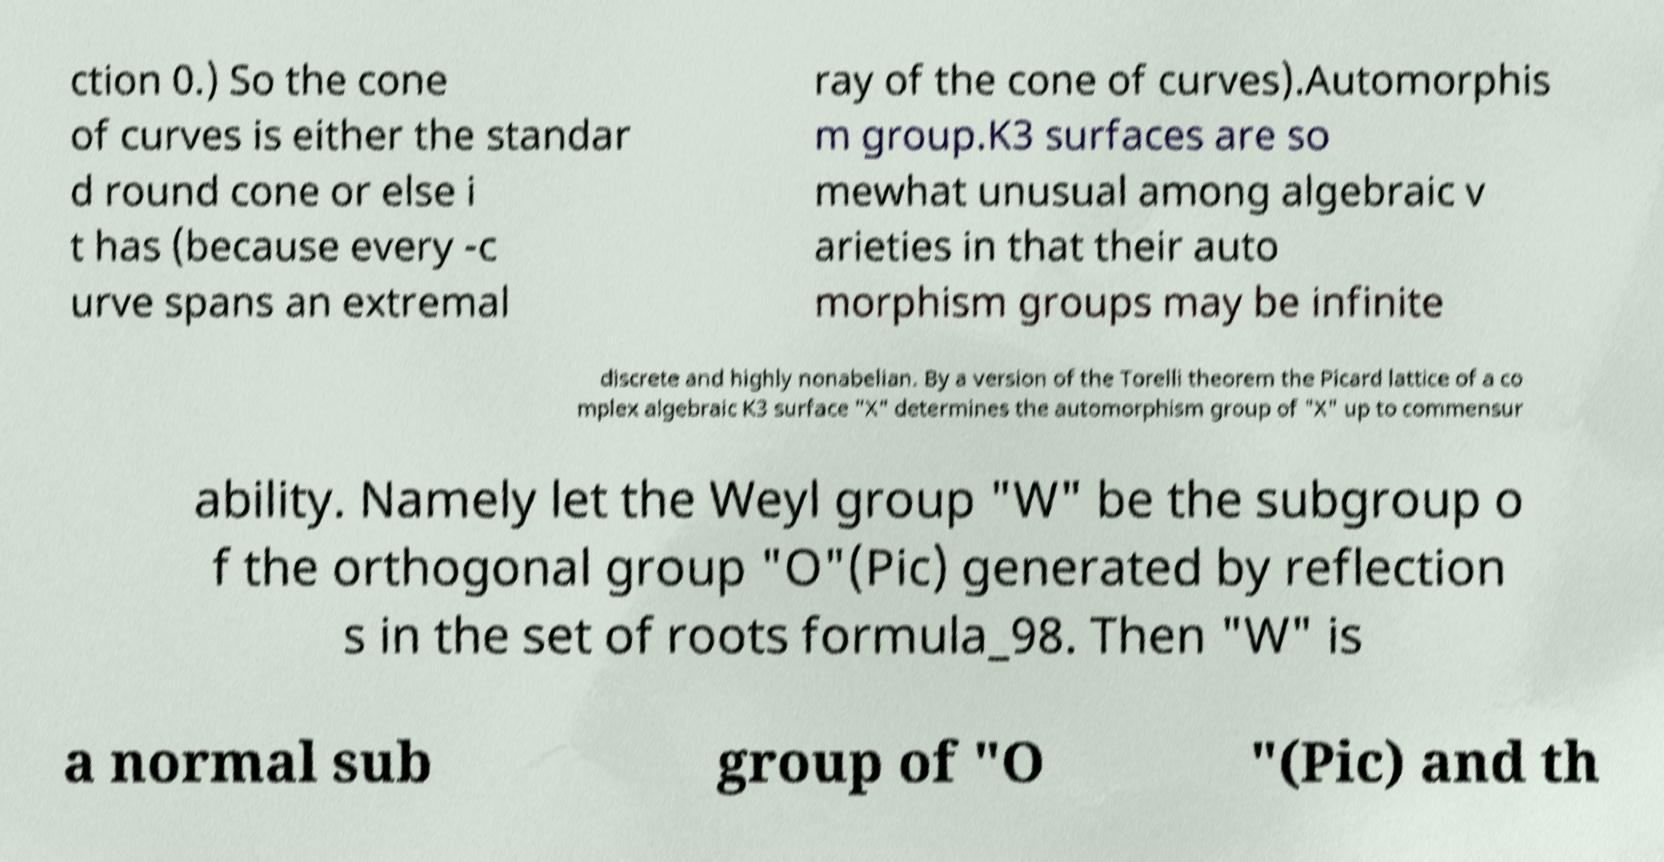Can you accurately transcribe the text from the provided image for me? ction 0.) So the cone of curves is either the standar d round cone or else i t has (because every -c urve spans an extremal ray of the cone of curves).Automorphis m group.K3 surfaces are so mewhat unusual among algebraic v arieties in that their auto morphism groups may be infinite discrete and highly nonabelian. By a version of the Torelli theorem the Picard lattice of a co mplex algebraic K3 surface "X" determines the automorphism group of "X" up to commensur ability. Namely let the Weyl group "W" be the subgroup o f the orthogonal group "O"(Pic) generated by reflection s in the set of roots formula_98. Then "W" is a normal sub group of "O "(Pic) and th 